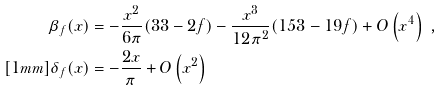Convert formula to latex. <formula><loc_0><loc_0><loc_500><loc_500>\beta _ { f } ( x ) & = - \frac { x ^ { 2 } } { 6 \pi } ( 3 3 - 2 f ) - \frac { x ^ { 3 } } { 1 2 \pi ^ { 2 } } ( 1 5 3 - 1 9 f ) + O \left ( x ^ { 4 } \right ) \ , \\ [ 1 m m ] \delta _ { f } ( x ) & = - \frac { 2 x } { \pi } + O \left ( x ^ { 2 } \right )</formula> 